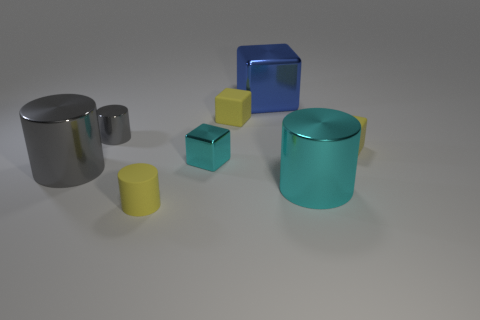Subtract all yellow blocks. How many were subtracted if there are1yellow blocks left? 1 Subtract all cyan spheres. How many gray cylinders are left? 2 Subtract all yellow rubber cylinders. How many cylinders are left? 3 Subtract all cyan cubes. How many cubes are left? 3 Add 1 small brown blocks. How many objects exist? 9 Subtract 2 cubes. How many cubes are left? 2 Subtract all yellow cylinders. Subtract all gray balls. How many cylinders are left? 3 Subtract 1 blue blocks. How many objects are left? 7 Subtract all large purple cubes. Subtract all shiny blocks. How many objects are left? 6 Add 5 small gray cylinders. How many small gray cylinders are left? 6 